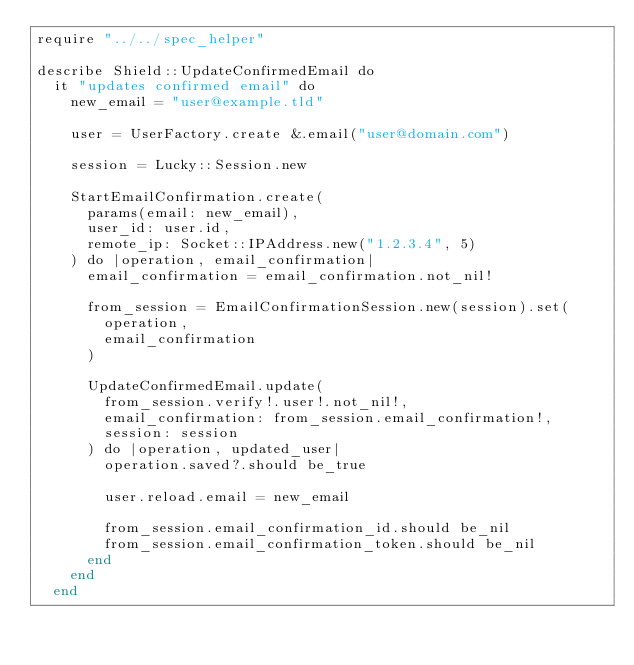<code> <loc_0><loc_0><loc_500><loc_500><_Crystal_>require "../../spec_helper"

describe Shield::UpdateConfirmedEmail do
  it "updates confirmed email" do
    new_email = "user@example.tld"

    user = UserFactory.create &.email("user@domain.com")

    session = Lucky::Session.new

    StartEmailConfirmation.create(
      params(email: new_email),
      user_id: user.id,
      remote_ip: Socket::IPAddress.new("1.2.3.4", 5)
    ) do |operation, email_confirmation|
      email_confirmation = email_confirmation.not_nil!

      from_session = EmailConfirmationSession.new(session).set(
        operation,
        email_confirmation
      )

      UpdateConfirmedEmail.update(
        from_session.verify!.user!.not_nil!,
        email_confirmation: from_session.email_confirmation!,
        session: session
      ) do |operation, updated_user|
        operation.saved?.should be_true

        user.reload.email = new_email

        from_session.email_confirmation_id.should be_nil
        from_session.email_confirmation_token.should be_nil
      end
    end
  end
</code> 